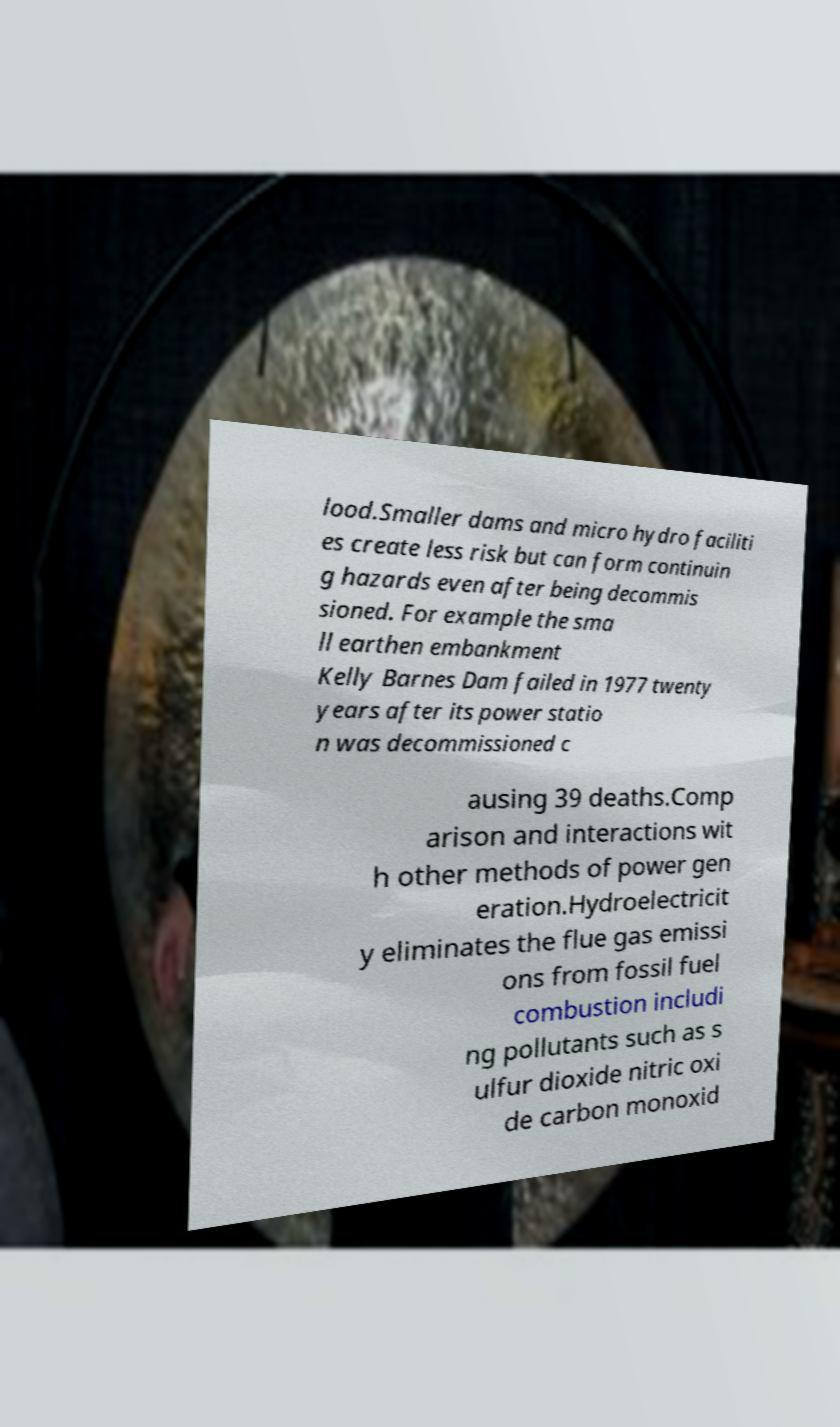Could you extract and type out the text from this image? lood.Smaller dams and micro hydro faciliti es create less risk but can form continuin g hazards even after being decommis sioned. For example the sma ll earthen embankment Kelly Barnes Dam failed in 1977 twenty years after its power statio n was decommissioned c ausing 39 deaths.Comp arison and interactions wit h other methods of power gen eration.Hydroelectricit y eliminates the flue gas emissi ons from fossil fuel combustion includi ng pollutants such as s ulfur dioxide nitric oxi de carbon monoxid 